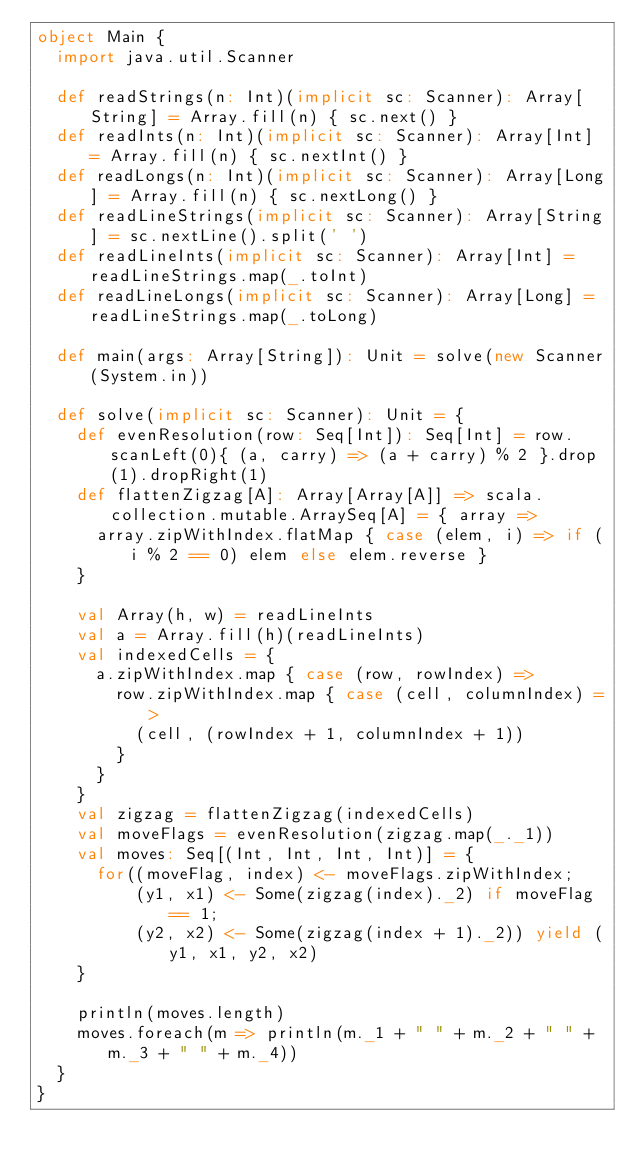<code> <loc_0><loc_0><loc_500><loc_500><_Scala_>object Main {
  import java.util.Scanner

  def readStrings(n: Int)(implicit sc: Scanner): Array[String] = Array.fill(n) { sc.next() }
  def readInts(n: Int)(implicit sc: Scanner): Array[Int] = Array.fill(n) { sc.nextInt() }
  def readLongs(n: Int)(implicit sc: Scanner): Array[Long] = Array.fill(n) { sc.nextLong() }
  def readLineStrings(implicit sc: Scanner): Array[String] = sc.nextLine().split(' ')
  def readLineInts(implicit sc: Scanner): Array[Int] = readLineStrings.map(_.toInt)
  def readLineLongs(implicit sc: Scanner): Array[Long] = readLineStrings.map(_.toLong)

  def main(args: Array[String]): Unit = solve(new Scanner(System.in))

  def solve(implicit sc: Scanner): Unit = {
    def evenResolution(row: Seq[Int]): Seq[Int] = row.scanLeft(0){ (a, carry) => (a + carry) % 2 }.drop(1).dropRight(1)
    def flattenZigzag[A]: Array[Array[A]] => scala.collection.mutable.ArraySeq[A] = { array =>
      array.zipWithIndex.flatMap { case (elem, i) => if (i % 2 == 0) elem else elem.reverse }
    }

    val Array(h, w) = readLineInts
    val a = Array.fill(h)(readLineInts)
    val indexedCells = {
      a.zipWithIndex.map { case (row, rowIndex) =>
        row.zipWithIndex.map { case (cell, columnIndex) =>
          (cell, (rowIndex + 1, columnIndex + 1))
        }
      }
    }
    val zigzag = flattenZigzag(indexedCells)
    val moveFlags = evenResolution(zigzag.map(_._1))
    val moves: Seq[(Int, Int, Int, Int)] = {
      for((moveFlag, index) <- moveFlags.zipWithIndex;
          (y1, x1) <- Some(zigzag(index)._2) if moveFlag == 1;
          (y2, x2) <- Some(zigzag(index + 1)._2)) yield (y1, x1, y2, x2)
    }

    println(moves.length)
    moves.foreach(m => println(m._1 + " " + m._2 + " " + m._3 + " " + m._4))
  }
}
</code> 